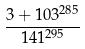<formula> <loc_0><loc_0><loc_500><loc_500>\frac { 3 + 1 0 3 ^ { 2 8 5 } } { 1 4 1 ^ { 2 9 5 } }</formula> 